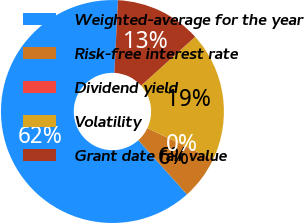Convert chart. <chart><loc_0><loc_0><loc_500><loc_500><pie_chart><fcel>Weighted-average for the year<fcel>Risk-free interest rate<fcel>Dividend yield<fcel>Volatility<fcel>Grant date fair value<nl><fcel>62.45%<fcel>6.26%<fcel>0.02%<fcel>18.75%<fcel>12.51%<nl></chart> 